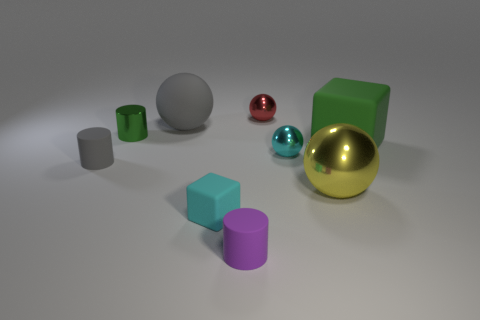What is the size of the sphere that is the same color as the small cube?
Keep it short and to the point. Small. Are there fewer cyan cubes that are behind the yellow sphere than small gray matte things?
Offer a terse response. Yes. What material is the tiny thing that is behind the gray object to the right of the small rubber cylinder that is behind the purple rubber object made of?
Offer a very short reply. Metal. Are there more small green shiny cylinders in front of the large yellow metallic thing than purple rubber things that are behind the small red sphere?
Your answer should be very brief. No. What number of rubber things are gray spheres or big green things?
Your answer should be very brief. 2. There is a matte thing that is the same color as the metal cylinder; what is its shape?
Your answer should be very brief. Cube. What is the tiny sphere behind the small cyan shiny thing made of?
Offer a terse response. Metal. How many things are rubber cylinders or large things that are on the left side of the cyan cube?
Ensure brevity in your answer.  3. The green rubber thing that is the same size as the yellow ball is what shape?
Offer a very short reply. Cube. What number of rubber balls have the same color as the tiny metallic cylinder?
Keep it short and to the point. 0. 